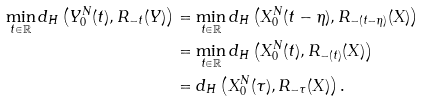<formula> <loc_0><loc_0><loc_500><loc_500>\min _ { t \in \mathbb { R } } d _ { H } \left ( Y _ { 0 } ^ { N } ( t ) , R _ { - t } ( Y ) \right ) & = \min _ { t \in \mathbb { R } } d _ { H } \left ( X _ { 0 } ^ { N } ( t - \eta ) , R _ { - ( t - \eta ) } ( X ) \right ) \\ & = \min _ { t \in \mathbb { R } } d _ { H } \left ( X _ { 0 } ^ { N } ( t ) , R _ { - ( t ) } ( X ) \right ) \\ & = d _ { H } \left ( X _ { 0 } ^ { N } ( \tau ) , R _ { - \tau } ( X ) \right ) .</formula> 